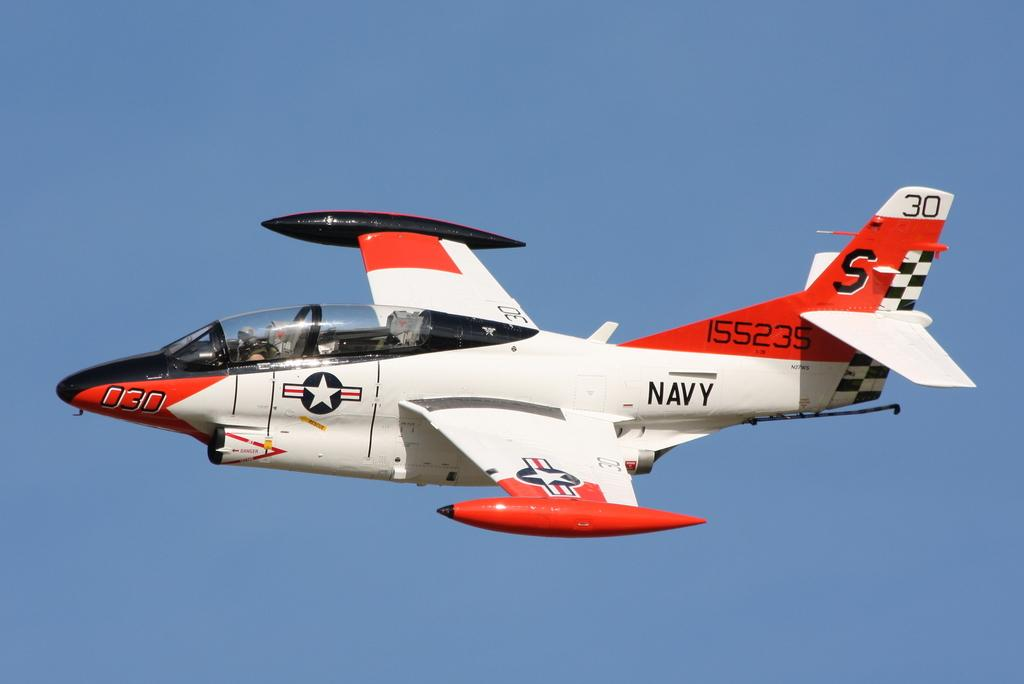<image>
Summarize the visual content of the image. A jet plane with the word Navy written on the side 